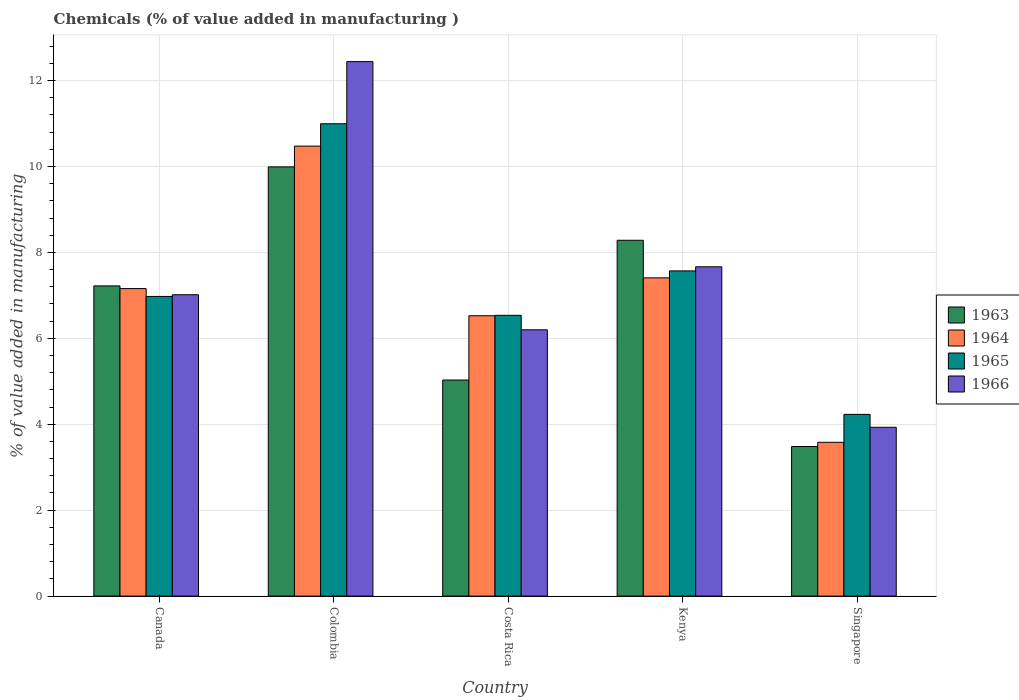How many different coloured bars are there?
Make the answer very short. 4. How many bars are there on the 3rd tick from the left?
Offer a terse response. 4. What is the value added in manufacturing chemicals in 1963 in Canada?
Your answer should be very brief. 7.22. Across all countries, what is the maximum value added in manufacturing chemicals in 1963?
Give a very brief answer. 9.99. Across all countries, what is the minimum value added in manufacturing chemicals in 1966?
Your response must be concise. 3.93. In which country was the value added in manufacturing chemicals in 1964 minimum?
Give a very brief answer. Singapore. What is the total value added in manufacturing chemicals in 1965 in the graph?
Your answer should be compact. 36.31. What is the difference between the value added in manufacturing chemicals in 1963 in Canada and that in Colombia?
Give a very brief answer. -2.77. What is the difference between the value added in manufacturing chemicals in 1966 in Canada and the value added in manufacturing chemicals in 1963 in Colombia?
Provide a succinct answer. -2.98. What is the average value added in manufacturing chemicals in 1963 per country?
Provide a short and direct response. 6.8. What is the difference between the value added in manufacturing chemicals of/in 1966 and value added in manufacturing chemicals of/in 1963 in Colombia?
Offer a terse response. 2.45. In how many countries, is the value added in manufacturing chemicals in 1964 greater than 4.4 %?
Provide a short and direct response. 4. What is the ratio of the value added in manufacturing chemicals in 1964 in Canada to that in Kenya?
Keep it short and to the point. 0.97. Is the value added in manufacturing chemicals in 1966 in Colombia less than that in Singapore?
Give a very brief answer. No. Is the difference between the value added in manufacturing chemicals in 1966 in Kenya and Singapore greater than the difference between the value added in manufacturing chemicals in 1963 in Kenya and Singapore?
Your response must be concise. No. What is the difference between the highest and the second highest value added in manufacturing chemicals in 1964?
Your response must be concise. 3.32. What is the difference between the highest and the lowest value added in manufacturing chemicals in 1963?
Offer a terse response. 6.51. In how many countries, is the value added in manufacturing chemicals in 1963 greater than the average value added in manufacturing chemicals in 1963 taken over all countries?
Your answer should be very brief. 3. Is the sum of the value added in manufacturing chemicals in 1963 in Colombia and Singapore greater than the maximum value added in manufacturing chemicals in 1964 across all countries?
Offer a very short reply. Yes. Is it the case that in every country, the sum of the value added in manufacturing chemicals in 1965 and value added in manufacturing chemicals in 1966 is greater than the sum of value added in manufacturing chemicals in 1963 and value added in manufacturing chemicals in 1964?
Your answer should be very brief. No. What does the 4th bar from the left in Singapore represents?
Your response must be concise. 1966. What does the 1st bar from the right in Canada represents?
Ensure brevity in your answer.  1966. Is it the case that in every country, the sum of the value added in manufacturing chemicals in 1963 and value added in manufacturing chemicals in 1965 is greater than the value added in manufacturing chemicals in 1966?
Offer a terse response. Yes. Does the graph contain any zero values?
Offer a very short reply. No. Does the graph contain grids?
Provide a short and direct response. Yes. How many legend labels are there?
Your response must be concise. 4. What is the title of the graph?
Keep it short and to the point. Chemicals (% of value added in manufacturing ). What is the label or title of the X-axis?
Make the answer very short. Country. What is the label or title of the Y-axis?
Offer a terse response. % of value added in manufacturing. What is the % of value added in manufacturing in 1963 in Canada?
Provide a short and direct response. 7.22. What is the % of value added in manufacturing of 1964 in Canada?
Provide a short and direct response. 7.16. What is the % of value added in manufacturing of 1965 in Canada?
Ensure brevity in your answer.  6.98. What is the % of value added in manufacturing in 1966 in Canada?
Ensure brevity in your answer.  7.01. What is the % of value added in manufacturing of 1963 in Colombia?
Keep it short and to the point. 9.99. What is the % of value added in manufacturing of 1964 in Colombia?
Keep it short and to the point. 10.47. What is the % of value added in manufacturing of 1965 in Colombia?
Offer a terse response. 10.99. What is the % of value added in manufacturing of 1966 in Colombia?
Your answer should be compact. 12.44. What is the % of value added in manufacturing of 1963 in Costa Rica?
Provide a short and direct response. 5.03. What is the % of value added in manufacturing of 1964 in Costa Rica?
Your answer should be compact. 6.53. What is the % of value added in manufacturing in 1965 in Costa Rica?
Your answer should be very brief. 6.54. What is the % of value added in manufacturing of 1966 in Costa Rica?
Offer a very short reply. 6.2. What is the % of value added in manufacturing of 1963 in Kenya?
Your response must be concise. 8.28. What is the % of value added in manufacturing in 1964 in Kenya?
Make the answer very short. 7.41. What is the % of value added in manufacturing in 1965 in Kenya?
Offer a very short reply. 7.57. What is the % of value added in manufacturing in 1966 in Kenya?
Provide a short and direct response. 7.67. What is the % of value added in manufacturing in 1963 in Singapore?
Your answer should be very brief. 3.48. What is the % of value added in manufacturing of 1964 in Singapore?
Give a very brief answer. 3.58. What is the % of value added in manufacturing in 1965 in Singapore?
Provide a short and direct response. 4.23. What is the % of value added in manufacturing in 1966 in Singapore?
Make the answer very short. 3.93. Across all countries, what is the maximum % of value added in manufacturing of 1963?
Ensure brevity in your answer.  9.99. Across all countries, what is the maximum % of value added in manufacturing in 1964?
Provide a short and direct response. 10.47. Across all countries, what is the maximum % of value added in manufacturing of 1965?
Offer a very short reply. 10.99. Across all countries, what is the maximum % of value added in manufacturing in 1966?
Your response must be concise. 12.44. Across all countries, what is the minimum % of value added in manufacturing of 1963?
Give a very brief answer. 3.48. Across all countries, what is the minimum % of value added in manufacturing of 1964?
Give a very brief answer. 3.58. Across all countries, what is the minimum % of value added in manufacturing of 1965?
Give a very brief answer. 4.23. Across all countries, what is the minimum % of value added in manufacturing in 1966?
Your answer should be very brief. 3.93. What is the total % of value added in manufacturing in 1963 in the graph?
Offer a terse response. 34.01. What is the total % of value added in manufacturing of 1964 in the graph?
Provide a succinct answer. 35.15. What is the total % of value added in manufacturing of 1965 in the graph?
Offer a very short reply. 36.31. What is the total % of value added in manufacturing in 1966 in the graph?
Offer a terse response. 37.25. What is the difference between the % of value added in manufacturing in 1963 in Canada and that in Colombia?
Provide a succinct answer. -2.77. What is the difference between the % of value added in manufacturing of 1964 in Canada and that in Colombia?
Give a very brief answer. -3.32. What is the difference between the % of value added in manufacturing of 1965 in Canada and that in Colombia?
Your answer should be compact. -4.02. What is the difference between the % of value added in manufacturing in 1966 in Canada and that in Colombia?
Provide a succinct answer. -5.43. What is the difference between the % of value added in manufacturing of 1963 in Canada and that in Costa Rica?
Your answer should be compact. 2.19. What is the difference between the % of value added in manufacturing of 1964 in Canada and that in Costa Rica?
Offer a terse response. 0.63. What is the difference between the % of value added in manufacturing in 1965 in Canada and that in Costa Rica?
Keep it short and to the point. 0.44. What is the difference between the % of value added in manufacturing in 1966 in Canada and that in Costa Rica?
Keep it short and to the point. 0.82. What is the difference between the % of value added in manufacturing of 1963 in Canada and that in Kenya?
Your answer should be compact. -1.06. What is the difference between the % of value added in manufacturing in 1964 in Canada and that in Kenya?
Your answer should be compact. -0.25. What is the difference between the % of value added in manufacturing in 1965 in Canada and that in Kenya?
Make the answer very short. -0.59. What is the difference between the % of value added in manufacturing of 1966 in Canada and that in Kenya?
Offer a very short reply. -0.65. What is the difference between the % of value added in manufacturing of 1963 in Canada and that in Singapore?
Your answer should be compact. 3.74. What is the difference between the % of value added in manufacturing of 1964 in Canada and that in Singapore?
Provide a short and direct response. 3.58. What is the difference between the % of value added in manufacturing of 1965 in Canada and that in Singapore?
Provide a short and direct response. 2.75. What is the difference between the % of value added in manufacturing in 1966 in Canada and that in Singapore?
Provide a succinct answer. 3.08. What is the difference between the % of value added in manufacturing of 1963 in Colombia and that in Costa Rica?
Your answer should be very brief. 4.96. What is the difference between the % of value added in manufacturing in 1964 in Colombia and that in Costa Rica?
Provide a short and direct response. 3.95. What is the difference between the % of value added in manufacturing of 1965 in Colombia and that in Costa Rica?
Your answer should be compact. 4.46. What is the difference between the % of value added in manufacturing of 1966 in Colombia and that in Costa Rica?
Offer a terse response. 6.24. What is the difference between the % of value added in manufacturing in 1963 in Colombia and that in Kenya?
Your answer should be compact. 1.71. What is the difference between the % of value added in manufacturing of 1964 in Colombia and that in Kenya?
Offer a terse response. 3.07. What is the difference between the % of value added in manufacturing of 1965 in Colombia and that in Kenya?
Provide a short and direct response. 3.43. What is the difference between the % of value added in manufacturing in 1966 in Colombia and that in Kenya?
Offer a very short reply. 4.78. What is the difference between the % of value added in manufacturing of 1963 in Colombia and that in Singapore?
Your response must be concise. 6.51. What is the difference between the % of value added in manufacturing of 1964 in Colombia and that in Singapore?
Offer a terse response. 6.89. What is the difference between the % of value added in manufacturing in 1965 in Colombia and that in Singapore?
Your answer should be very brief. 6.76. What is the difference between the % of value added in manufacturing of 1966 in Colombia and that in Singapore?
Give a very brief answer. 8.51. What is the difference between the % of value added in manufacturing in 1963 in Costa Rica and that in Kenya?
Provide a succinct answer. -3.25. What is the difference between the % of value added in manufacturing of 1964 in Costa Rica and that in Kenya?
Make the answer very short. -0.88. What is the difference between the % of value added in manufacturing of 1965 in Costa Rica and that in Kenya?
Keep it short and to the point. -1.03. What is the difference between the % of value added in manufacturing of 1966 in Costa Rica and that in Kenya?
Give a very brief answer. -1.47. What is the difference between the % of value added in manufacturing in 1963 in Costa Rica and that in Singapore?
Offer a very short reply. 1.55. What is the difference between the % of value added in manufacturing in 1964 in Costa Rica and that in Singapore?
Your answer should be very brief. 2.95. What is the difference between the % of value added in manufacturing of 1965 in Costa Rica and that in Singapore?
Offer a terse response. 2.31. What is the difference between the % of value added in manufacturing of 1966 in Costa Rica and that in Singapore?
Make the answer very short. 2.27. What is the difference between the % of value added in manufacturing of 1963 in Kenya and that in Singapore?
Provide a succinct answer. 4.8. What is the difference between the % of value added in manufacturing of 1964 in Kenya and that in Singapore?
Give a very brief answer. 3.83. What is the difference between the % of value added in manufacturing in 1965 in Kenya and that in Singapore?
Your answer should be very brief. 3.34. What is the difference between the % of value added in manufacturing of 1966 in Kenya and that in Singapore?
Offer a very short reply. 3.74. What is the difference between the % of value added in manufacturing of 1963 in Canada and the % of value added in manufacturing of 1964 in Colombia?
Your answer should be compact. -3.25. What is the difference between the % of value added in manufacturing of 1963 in Canada and the % of value added in manufacturing of 1965 in Colombia?
Your answer should be very brief. -3.77. What is the difference between the % of value added in manufacturing in 1963 in Canada and the % of value added in manufacturing in 1966 in Colombia?
Offer a terse response. -5.22. What is the difference between the % of value added in manufacturing of 1964 in Canada and the % of value added in manufacturing of 1965 in Colombia?
Provide a succinct answer. -3.84. What is the difference between the % of value added in manufacturing of 1964 in Canada and the % of value added in manufacturing of 1966 in Colombia?
Keep it short and to the point. -5.28. What is the difference between the % of value added in manufacturing of 1965 in Canada and the % of value added in manufacturing of 1966 in Colombia?
Your response must be concise. -5.47. What is the difference between the % of value added in manufacturing of 1963 in Canada and the % of value added in manufacturing of 1964 in Costa Rica?
Keep it short and to the point. 0.69. What is the difference between the % of value added in manufacturing in 1963 in Canada and the % of value added in manufacturing in 1965 in Costa Rica?
Make the answer very short. 0.68. What is the difference between the % of value added in manufacturing of 1963 in Canada and the % of value added in manufacturing of 1966 in Costa Rica?
Give a very brief answer. 1.02. What is the difference between the % of value added in manufacturing in 1964 in Canada and the % of value added in manufacturing in 1965 in Costa Rica?
Your answer should be very brief. 0.62. What is the difference between the % of value added in manufacturing in 1964 in Canada and the % of value added in manufacturing in 1966 in Costa Rica?
Make the answer very short. 0.96. What is the difference between the % of value added in manufacturing of 1965 in Canada and the % of value added in manufacturing of 1966 in Costa Rica?
Give a very brief answer. 0.78. What is the difference between the % of value added in manufacturing of 1963 in Canada and the % of value added in manufacturing of 1964 in Kenya?
Provide a short and direct response. -0.19. What is the difference between the % of value added in manufacturing of 1963 in Canada and the % of value added in manufacturing of 1965 in Kenya?
Offer a very short reply. -0.35. What is the difference between the % of value added in manufacturing of 1963 in Canada and the % of value added in manufacturing of 1966 in Kenya?
Offer a very short reply. -0.44. What is the difference between the % of value added in manufacturing of 1964 in Canada and the % of value added in manufacturing of 1965 in Kenya?
Provide a short and direct response. -0.41. What is the difference between the % of value added in manufacturing of 1964 in Canada and the % of value added in manufacturing of 1966 in Kenya?
Provide a short and direct response. -0.51. What is the difference between the % of value added in manufacturing of 1965 in Canada and the % of value added in manufacturing of 1966 in Kenya?
Offer a very short reply. -0.69. What is the difference between the % of value added in manufacturing in 1963 in Canada and the % of value added in manufacturing in 1964 in Singapore?
Ensure brevity in your answer.  3.64. What is the difference between the % of value added in manufacturing in 1963 in Canada and the % of value added in manufacturing in 1965 in Singapore?
Provide a succinct answer. 2.99. What is the difference between the % of value added in manufacturing of 1963 in Canada and the % of value added in manufacturing of 1966 in Singapore?
Your answer should be compact. 3.29. What is the difference between the % of value added in manufacturing in 1964 in Canada and the % of value added in manufacturing in 1965 in Singapore?
Provide a succinct answer. 2.93. What is the difference between the % of value added in manufacturing of 1964 in Canada and the % of value added in manufacturing of 1966 in Singapore?
Ensure brevity in your answer.  3.23. What is the difference between the % of value added in manufacturing in 1965 in Canada and the % of value added in manufacturing in 1966 in Singapore?
Provide a succinct answer. 3.05. What is the difference between the % of value added in manufacturing of 1963 in Colombia and the % of value added in manufacturing of 1964 in Costa Rica?
Offer a terse response. 3.47. What is the difference between the % of value added in manufacturing of 1963 in Colombia and the % of value added in manufacturing of 1965 in Costa Rica?
Give a very brief answer. 3.46. What is the difference between the % of value added in manufacturing in 1963 in Colombia and the % of value added in manufacturing in 1966 in Costa Rica?
Make the answer very short. 3.79. What is the difference between the % of value added in manufacturing of 1964 in Colombia and the % of value added in manufacturing of 1965 in Costa Rica?
Provide a succinct answer. 3.94. What is the difference between the % of value added in manufacturing of 1964 in Colombia and the % of value added in manufacturing of 1966 in Costa Rica?
Offer a terse response. 4.28. What is the difference between the % of value added in manufacturing of 1965 in Colombia and the % of value added in manufacturing of 1966 in Costa Rica?
Make the answer very short. 4.8. What is the difference between the % of value added in manufacturing of 1963 in Colombia and the % of value added in manufacturing of 1964 in Kenya?
Give a very brief answer. 2.58. What is the difference between the % of value added in manufacturing in 1963 in Colombia and the % of value added in manufacturing in 1965 in Kenya?
Offer a very short reply. 2.42. What is the difference between the % of value added in manufacturing in 1963 in Colombia and the % of value added in manufacturing in 1966 in Kenya?
Offer a very short reply. 2.33. What is the difference between the % of value added in manufacturing of 1964 in Colombia and the % of value added in manufacturing of 1965 in Kenya?
Your answer should be very brief. 2.9. What is the difference between the % of value added in manufacturing in 1964 in Colombia and the % of value added in manufacturing in 1966 in Kenya?
Make the answer very short. 2.81. What is the difference between the % of value added in manufacturing of 1965 in Colombia and the % of value added in manufacturing of 1966 in Kenya?
Provide a succinct answer. 3.33. What is the difference between the % of value added in manufacturing in 1963 in Colombia and the % of value added in manufacturing in 1964 in Singapore?
Make the answer very short. 6.41. What is the difference between the % of value added in manufacturing of 1963 in Colombia and the % of value added in manufacturing of 1965 in Singapore?
Keep it short and to the point. 5.76. What is the difference between the % of value added in manufacturing of 1963 in Colombia and the % of value added in manufacturing of 1966 in Singapore?
Provide a succinct answer. 6.06. What is the difference between the % of value added in manufacturing in 1964 in Colombia and the % of value added in manufacturing in 1965 in Singapore?
Provide a succinct answer. 6.24. What is the difference between the % of value added in manufacturing of 1964 in Colombia and the % of value added in manufacturing of 1966 in Singapore?
Your response must be concise. 6.54. What is the difference between the % of value added in manufacturing of 1965 in Colombia and the % of value added in manufacturing of 1966 in Singapore?
Provide a short and direct response. 7.07. What is the difference between the % of value added in manufacturing in 1963 in Costa Rica and the % of value added in manufacturing in 1964 in Kenya?
Offer a very short reply. -2.38. What is the difference between the % of value added in manufacturing of 1963 in Costa Rica and the % of value added in manufacturing of 1965 in Kenya?
Offer a terse response. -2.54. What is the difference between the % of value added in manufacturing of 1963 in Costa Rica and the % of value added in manufacturing of 1966 in Kenya?
Offer a very short reply. -2.64. What is the difference between the % of value added in manufacturing in 1964 in Costa Rica and the % of value added in manufacturing in 1965 in Kenya?
Ensure brevity in your answer.  -1.04. What is the difference between the % of value added in manufacturing in 1964 in Costa Rica and the % of value added in manufacturing in 1966 in Kenya?
Your answer should be compact. -1.14. What is the difference between the % of value added in manufacturing of 1965 in Costa Rica and the % of value added in manufacturing of 1966 in Kenya?
Offer a very short reply. -1.13. What is the difference between the % of value added in manufacturing of 1963 in Costa Rica and the % of value added in manufacturing of 1964 in Singapore?
Provide a succinct answer. 1.45. What is the difference between the % of value added in manufacturing of 1963 in Costa Rica and the % of value added in manufacturing of 1965 in Singapore?
Give a very brief answer. 0.8. What is the difference between the % of value added in manufacturing in 1963 in Costa Rica and the % of value added in manufacturing in 1966 in Singapore?
Your response must be concise. 1.1. What is the difference between the % of value added in manufacturing in 1964 in Costa Rica and the % of value added in manufacturing in 1965 in Singapore?
Keep it short and to the point. 2.3. What is the difference between the % of value added in manufacturing in 1964 in Costa Rica and the % of value added in manufacturing in 1966 in Singapore?
Keep it short and to the point. 2.6. What is the difference between the % of value added in manufacturing in 1965 in Costa Rica and the % of value added in manufacturing in 1966 in Singapore?
Your answer should be compact. 2.61. What is the difference between the % of value added in manufacturing in 1963 in Kenya and the % of value added in manufacturing in 1964 in Singapore?
Offer a terse response. 4.7. What is the difference between the % of value added in manufacturing in 1963 in Kenya and the % of value added in manufacturing in 1965 in Singapore?
Offer a terse response. 4.05. What is the difference between the % of value added in manufacturing in 1963 in Kenya and the % of value added in manufacturing in 1966 in Singapore?
Your answer should be very brief. 4.35. What is the difference between the % of value added in manufacturing of 1964 in Kenya and the % of value added in manufacturing of 1965 in Singapore?
Provide a short and direct response. 3.18. What is the difference between the % of value added in manufacturing of 1964 in Kenya and the % of value added in manufacturing of 1966 in Singapore?
Your answer should be compact. 3.48. What is the difference between the % of value added in manufacturing of 1965 in Kenya and the % of value added in manufacturing of 1966 in Singapore?
Provide a short and direct response. 3.64. What is the average % of value added in manufacturing of 1963 per country?
Provide a short and direct response. 6.8. What is the average % of value added in manufacturing in 1964 per country?
Your response must be concise. 7.03. What is the average % of value added in manufacturing of 1965 per country?
Provide a succinct answer. 7.26. What is the average % of value added in manufacturing of 1966 per country?
Make the answer very short. 7.45. What is the difference between the % of value added in manufacturing in 1963 and % of value added in manufacturing in 1964 in Canada?
Give a very brief answer. 0.06. What is the difference between the % of value added in manufacturing in 1963 and % of value added in manufacturing in 1965 in Canada?
Your answer should be very brief. 0.25. What is the difference between the % of value added in manufacturing of 1963 and % of value added in manufacturing of 1966 in Canada?
Your answer should be compact. 0.21. What is the difference between the % of value added in manufacturing of 1964 and % of value added in manufacturing of 1965 in Canada?
Give a very brief answer. 0.18. What is the difference between the % of value added in manufacturing of 1964 and % of value added in manufacturing of 1966 in Canada?
Your response must be concise. 0.14. What is the difference between the % of value added in manufacturing in 1965 and % of value added in manufacturing in 1966 in Canada?
Offer a very short reply. -0.04. What is the difference between the % of value added in manufacturing in 1963 and % of value added in manufacturing in 1964 in Colombia?
Provide a succinct answer. -0.48. What is the difference between the % of value added in manufacturing in 1963 and % of value added in manufacturing in 1965 in Colombia?
Ensure brevity in your answer.  -1. What is the difference between the % of value added in manufacturing in 1963 and % of value added in manufacturing in 1966 in Colombia?
Your response must be concise. -2.45. What is the difference between the % of value added in manufacturing in 1964 and % of value added in manufacturing in 1965 in Colombia?
Offer a very short reply. -0.52. What is the difference between the % of value added in manufacturing in 1964 and % of value added in manufacturing in 1966 in Colombia?
Give a very brief answer. -1.97. What is the difference between the % of value added in manufacturing of 1965 and % of value added in manufacturing of 1966 in Colombia?
Ensure brevity in your answer.  -1.45. What is the difference between the % of value added in manufacturing of 1963 and % of value added in manufacturing of 1964 in Costa Rica?
Your answer should be very brief. -1.5. What is the difference between the % of value added in manufacturing of 1963 and % of value added in manufacturing of 1965 in Costa Rica?
Make the answer very short. -1.51. What is the difference between the % of value added in manufacturing of 1963 and % of value added in manufacturing of 1966 in Costa Rica?
Provide a succinct answer. -1.17. What is the difference between the % of value added in manufacturing of 1964 and % of value added in manufacturing of 1965 in Costa Rica?
Keep it short and to the point. -0.01. What is the difference between the % of value added in manufacturing in 1964 and % of value added in manufacturing in 1966 in Costa Rica?
Ensure brevity in your answer.  0.33. What is the difference between the % of value added in manufacturing of 1965 and % of value added in manufacturing of 1966 in Costa Rica?
Make the answer very short. 0.34. What is the difference between the % of value added in manufacturing of 1963 and % of value added in manufacturing of 1964 in Kenya?
Provide a short and direct response. 0.87. What is the difference between the % of value added in manufacturing of 1963 and % of value added in manufacturing of 1965 in Kenya?
Keep it short and to the point. 0.71. What is the difference between the % of value added in manufacturing in 1963 and % of value added in manufacturing in 1966 in Kenya?
Your response must be concise. 0.62. What is the difference between the % of value added in manufacturing of 1964 and % of value added in manufacturing of 1965 in Kenya?
Give a very brief answer. -0.16. What is the difference between the % of value added in manufacturing in 1964 and % of value added in manufacturing in 1966 in Kenya?
Provide a succinct answer. -0.26. What is the difference between the % of value added in manufacturing in 1965 and % of value added in manufacturing in 1966 in Kenya?
Give a very brief answer. -0.1. What is the difference between the % of value added in manufacturing of 1963 and % of value added in manufacturing of 1964 in Singapore?
Give a very brief answer. -0.1. What is the difference between the % of value added in manufacturing of 1963 and % of value added in manufacturing of 1965 in Singapore?
Give a very brief answer. -0.75. What is the difference between the % of value added in manufacturing of 1963 and % of value added in manufacturing of 1966 in Singapore?
Your answer should be very brief. -0.45. What is the difference between the % of value added in manufacturing of 1964 and % of value added in manufacturing of 1965 in Singapore?
Give a very brief answer. -0.65. What is the difference between the % of value added in manufacturing of 1964 and % of value added in manufacturing of 1966 in Singapore?
Your answer should be compact. -0.35. What is the difference between the % of value added in manufacturing of 1965 and % of value added in manufacturing of 1966 in Singapore?
Offer a very short reply. 0.3. What is the ratio of the % of value added in manufacturing of 1963 in Canada to that in Colombia?
Make the answer very short. 0.72. What is the ratio of the % of value added in manufacturing of 1964 in Canada to that in Colombia?
Provide a short and direct response. 0.68. What is the ratio of the % of value added in manufacturing in 1965 in Canada to that in Colombia?
Keep it short and to the point. 0.63. What is the ratio of the % of value added in manufacturing in 1966 in Canada to that in Colombia?
Make the answer very short. 0.56. What is the ratio of the % of value added in manufacturing of 1963 in Canada to that in Costa Rica?
Give a very brief answer. 1.44. What is the ratio of the % of value added in manufacturing in 1964 in Canada to that in Costa Rica?
Your answer should be very brief. 1.1. What is the ratio of the % of value added in manufacturing in 1965 in Canada to that in Costa Rica?
Make the answer very short. 1.07. What is the ratio of the % of value added in manufacturing of 1966 in Canada to that in Costa Rica?
Offer a very short reply. 1.13. What is the ratio of the % of value added in manufacturing of 1963 in Canada to that in Kenya?
Keep it short and to the point. 0.87. What is the ratio of the % of value added in manufacturing of 1964 in Canada to that in Kenya?
Your answer should be very brief. 0.97. What is the ratio of the % of value added in manufacturing in 1965 in Canada to that in Kenya?
Your response must be concise. 0.92. What is the ratio of the % of value added in manufacturing in 1966 in Canada to that in Kenya?
Provide a succinct answer. 0.92. What is the ratio of the % of value added in manufacturing of 1963 in Canada to that in Singapore?
Offer a very short reply. 2.07. What is the ratio of the % of value added in manufacturing of 1964 in Canada to that in Singapore?
Your answer should be very brief. 2. What is the ratio of the % of value added in manufacturing of 1965 in Canada to that in Singapore?
Your answer should be very brief. 1.65. What is the ratio of the % of value added in manufacturing in 1966 in Canada to that in Singapore?
Provide a succinct answer. 1.78. What is the ratio of the % of value added in manufacturing in 1963 in Colombia to that in Costa Rica?
Provide a succinct answer. 1.99. What is the ratio of the % of value added in manufacturing of 1964 in Colombia to that in Costa Rica?
Offer a terse response. 1.61. What is the ratio of the % of value added in manufacturing in 1965 in Colombia to that in Costa Rica?
Provide a short and direct response. 1.68. What is the ratio of the % of value added in manufacturing of 1966 in Colombia to that in Costa Rica?
Provide a succinct answer. 2.01. What is the ratio of the % of value added in manufacturing in 1963 in Colombia to that in Kenya?
Offer a very short reply. 1.21. What is the ratio of the % of value added in manufacturing of 1964 in Colombia to that in Kenya?
Provide a succinct answer. 1.41. What is the ratio of the % of value added in manufacturing in 1965 in Colombia to that in Kenya?
Make the answer very short. 1.45. What is the ratio of the % of value added in manufacturing in 1966 in Colombia to that in Kenya?
Ensure brevity in your answer.  1.62. What is the ratio of the % of value added in manufacturing of 1963 in Colombia to that in Singapore?
Provide a succinct answer. 2.87. What is the ratio of the % of value added in manufacturing in 1964 in Colombia to that in Singapore?
Your response must be concise. 2.93. What is the ratio of the % of value added in manufacturing of 1965 in Colombia to that in Singapore?
Keep it short and to the point. 2.6. What is the ratio of the % of value added in manufacturing in 1966 in Colombia to that in Singapore?
Your response must be concise. 3.17. What is the ratio of the % of value added in manufacturing of 1963 in Costa Rica to that in Kenya?
Your response must be concise. 0.61. What is the ratio of the % of value added in manufacturing of 1964 in Costa Rica to that in Kenya?
Make the answer very short. 0.88. What is the ratio of the % of value added in manufacturing in 1965 in Costa Rica to that in Kenya?
Give a very brief answer. 0.86. What is the ratio of the % of value added in manufacturing of 1966 in Costa Rica to that in Kenya?
Offer a very short reply. 0.81. What is the ratio of the % of value added in manufacturing of 1963 in Costa Rica to that in Singapore?
Provide a succinct answer. 1.44. What is the ratio of the % of value added in manufacturing in 1964 in Costa Rica to that in Singapore?
Offer a very short reply. 1.82. What is the ratio of the % of value added in manufacturing of 1965 in Costa Rica to that in Singapore?
Your response must be concise. 1.55. What is the ratio of the % of value added in manufacturing in 1966 in Costa Rica to that in Singapore?
Keep it short and to the point. 1.58. What is the ratio of the % of value added in manufacturing of 1963 in Kenya to that in Singapore?
Offer a terse response. 2.38. What is the ratio of the % of value added in manufacturing in 1964 in Kenya to that in Singapore?
Provide a succinct answer. 2.07. What is the ratio of the % of value added in manufacturing of 1965 in Kenya to that in Singapore?
Your answer should be compact. 1.79. What is the ratio of the % of value added in manufacturing of 1966 in Kenya to that in Singapore?
Your answer should be very brief. 1.95. What is the difference between the highest and the second highest % of value added in manufacturing of 1963?
Give a very brief answer. 1.71. What is the difference between the highest and the second highest % of value added in manufacturing in 1964?
Provide a short and direct response. 3.07. What is the difference between the highest and the second highest % of value added in manufacturing of 1965?
Your response must be concise. 3.43. What is the difference between the highest and the second highest % of value added in manufacturing of 1966?
Your answer should be very brief. 4.78. What is the difference between the highest and the lowest % of value added in manufacturing of 1963?
Your response must be concise. 6.51. What is the difference between the highest and the lowest % of value added in manufacturing in 1964?
Offer a terse response. 6.89. What is the difference between the highest and the lowest % of value added in manufacturing in 1965?
Give a very brief answer. 6.76. What is the difference between the highest and the lowest % of value added in manufacturing in 1966?
Keep it short and to the point. 8.51. 